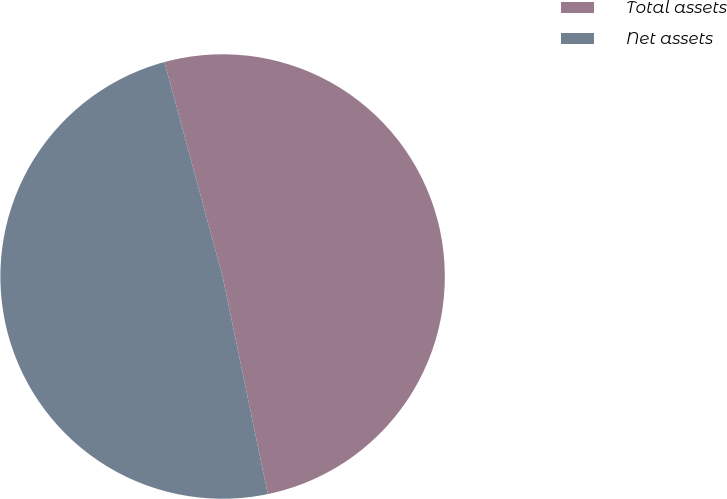<chart> <loc_0><loc_0><loc_500><loc_500><pie_chart><fcel>Total assets<fcel>Net assets<nl><fcel>50.96%<fcel>49.04%<nl></chart> 